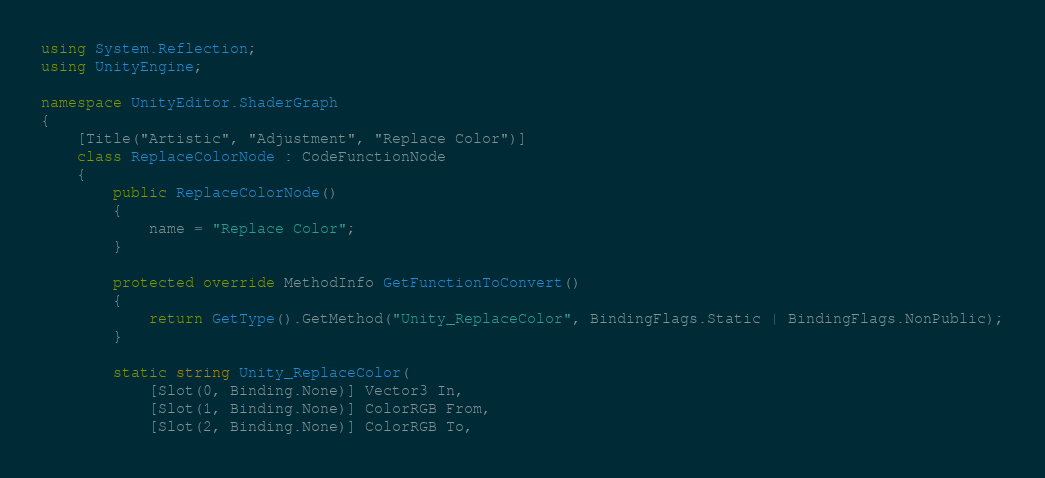Convert code to text. <code><loc_0><loc_0><loc_500><loc_500><_C#_>using System.Reflection;
using UnityEngine;

namespace UnityEditor.ShaderGraph
{
    [Title("Artistic", "Adjustment", "Replace Color")]
    class ReplaceColorNode : CodeFunctionNode
    {
        public ReplaceColorNode()
        {
            name = "Replace Color";
        }

        protected override MethodInfo GetFunctionToConvert()
        {
            return GetType().GetMethod("Unity_ReplaceColor", BindingFlags.Static | BindingFlags.NonPublic);
        }

        static string Unity_ReplaceColor(
            [Slot(0, Binding.None)] Vector3 In,
            [Slot(1, Binding.None)] ColorRGB From,
            [Slot(2, Binding.None)] ColorRGB To,</code> 